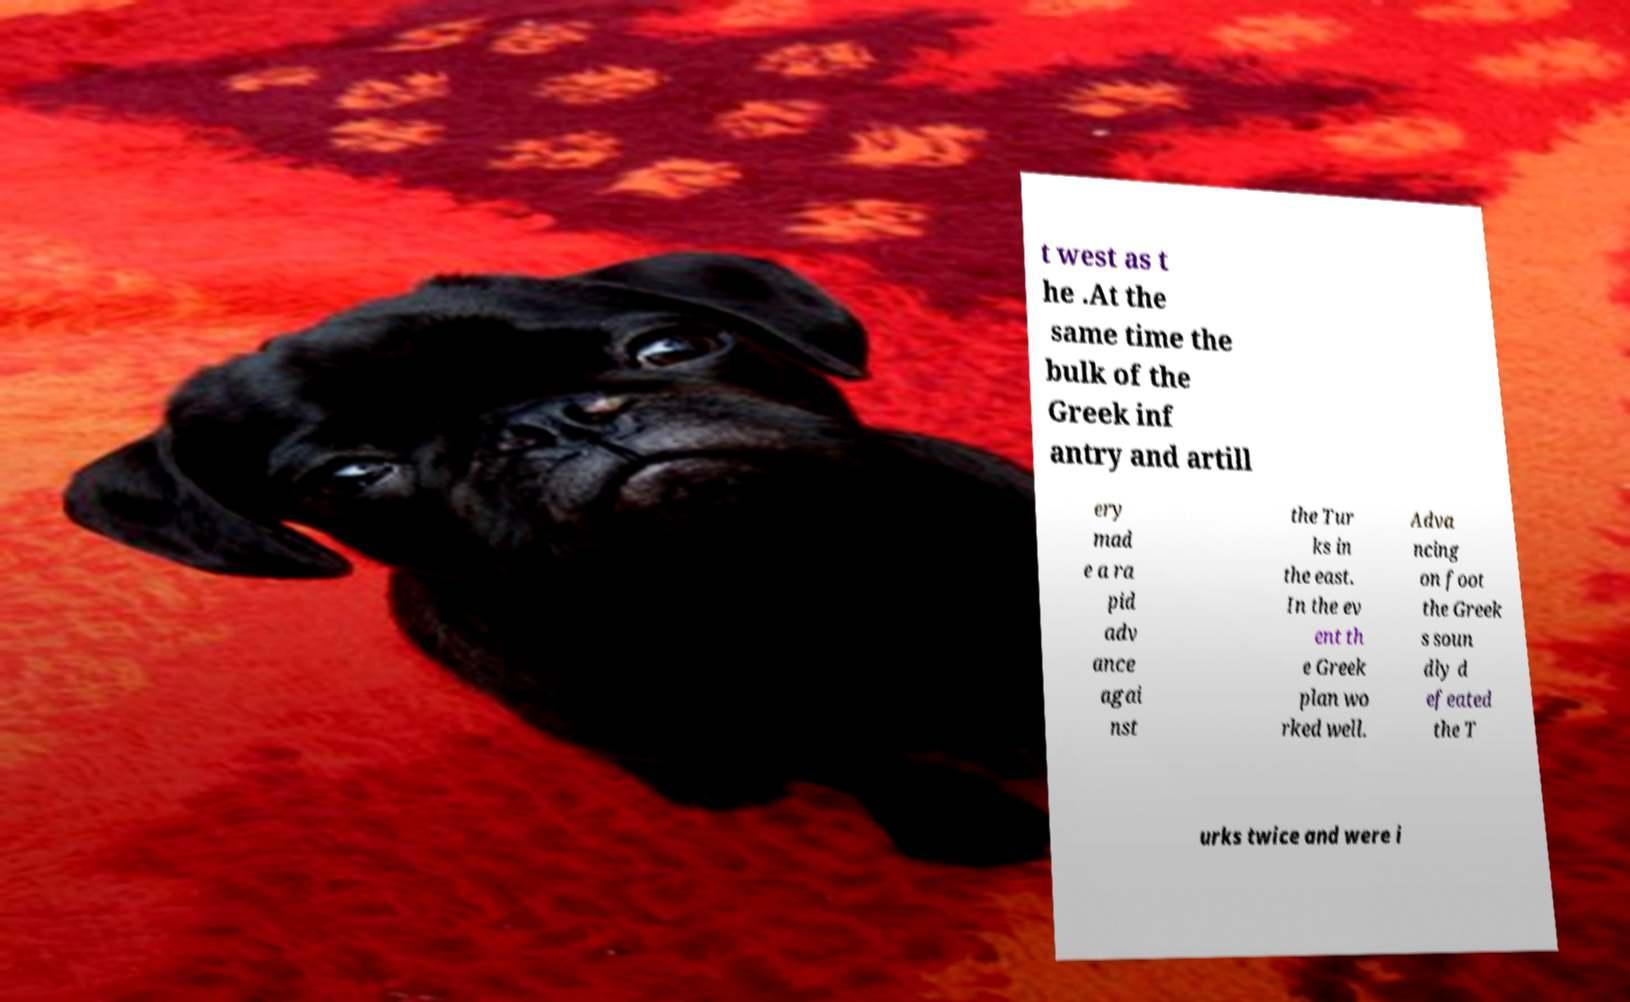Can you accurately transcribe the text from the provided image for me? t west as t he .At the same time the bulk of the Greek inf antry and artill ery mad e a ra pid adv ance agai nst the Tur ks in the east. In the ev ent th e Greek plan wo rked well. Adva ncing on foot the Greek s soun dly d efeated the T urks twice and were i 